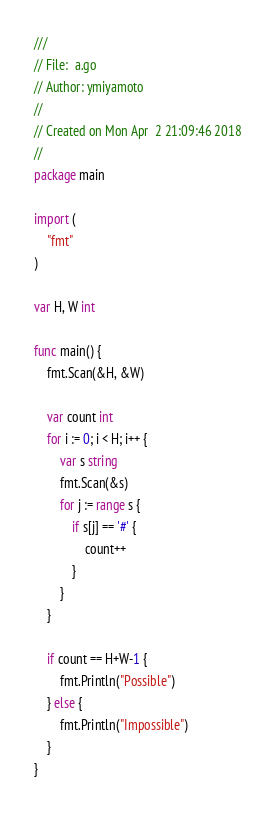<code> <loc_0><loc_0><loc_500><loc_500><_Go_>///
// File:  a.go
// Author: ymiyamoto
//
// Created on Mon Apr  2 21:09:46 2018
//
package main

import (
	"fmt"
)

var H, W int

func main() {
	fmt.Scan(&H, &W)

	var count int
	for i := 0; i < H; i++ {
		var s string
		fmt.Scan(&s)
		for j := range s {
			if s[j] == '#' {
				count++
			}
		}
	}

	if count == H+W-1 {
		fmt.Println("Possible")
	} else {
		fmt.Println("Impossible")
	}
}
</code> 